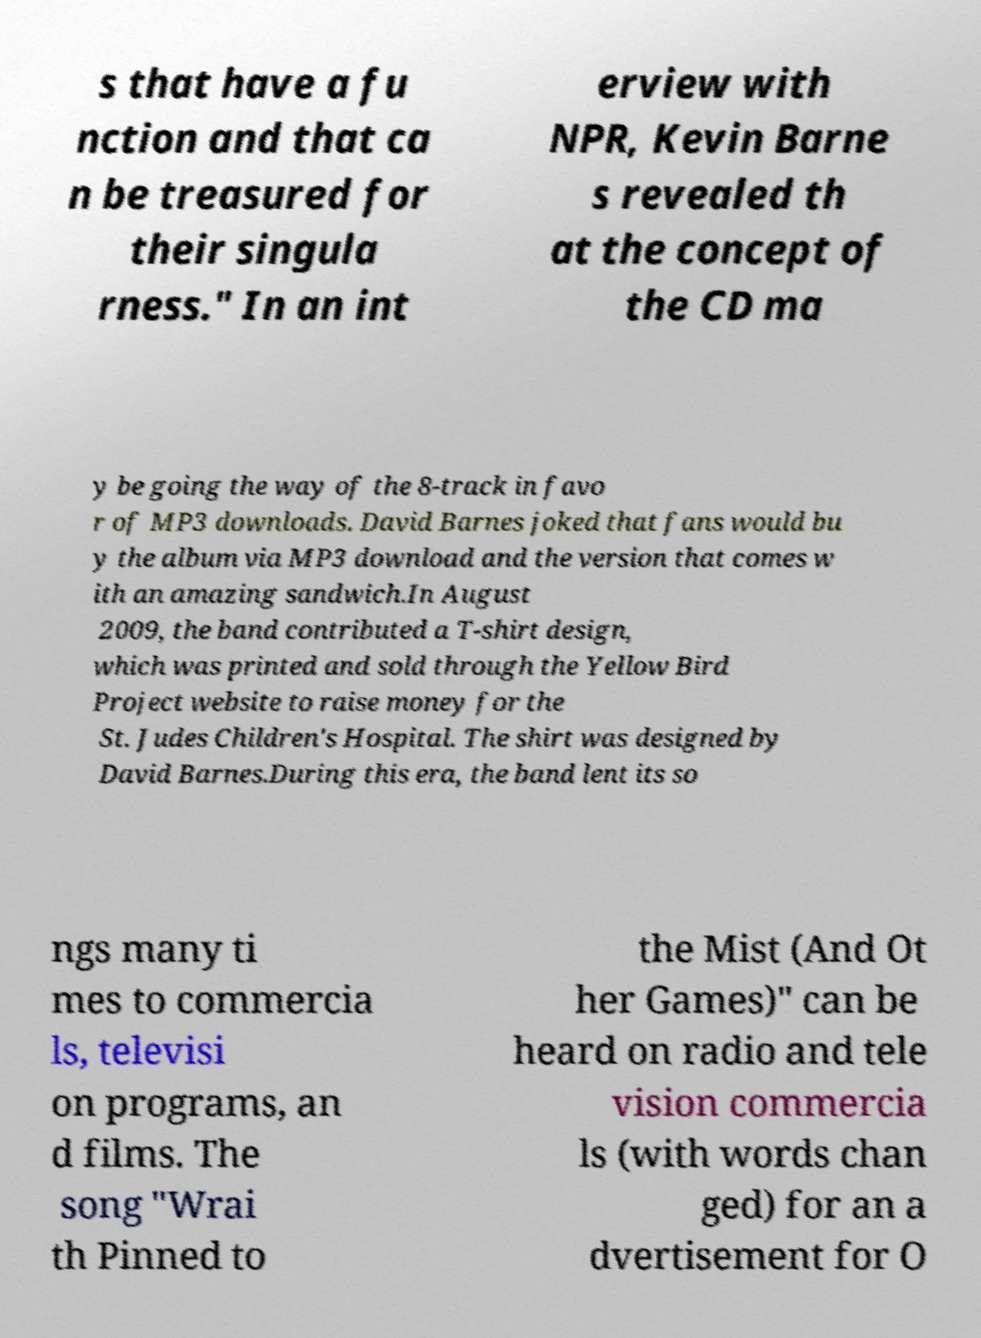There's text embedded in this image that I need extracted. Can you transcribe it verbatim? s that have a fu nction and that ca n be treasured for their singula rness." In an int erview with NPR, Kevin Barne s revealed th at the concept of the CD ma y be going the way of the 8-track in favo r of MP3 downloads. David Barnes joked that fans would bu y the album via MP3 download and the version that comes w ith an amazing sandwich.In August 2009, the band contributed a T-shirt design, which was printed and sold through the Yellow Bird Project website to raise money for the St. Judes Children's Hospital. The shirt was designed by David Barnes.During this era, the band lent its so ngs many ti mes to commercia ls, televisi on programs, an d films. The song "Wrai th Pinned to the Mist (And Ot her Games)" can be heard on radio and tele vision commercia ls (with words chan ged) for an a dvertisement for O 